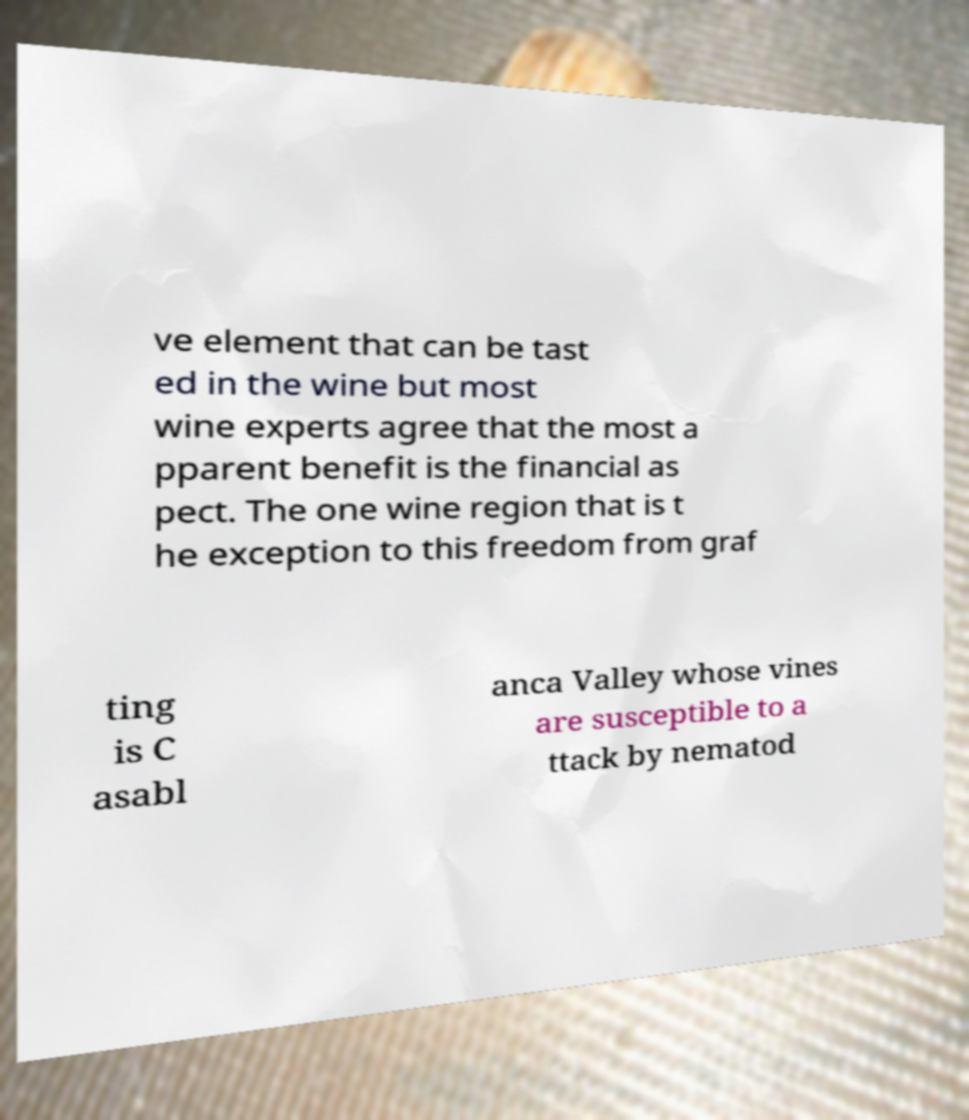Please identify and transcribe the text found in this image. ve element that can be tast ed in the wine but most wine experts agree that the most a pparent benefit is the financial as pect. The one wine region that is t he exception to this freedom from graf ting is C asabl anca Valley whose vines are susceptible to a ttack by nematod 